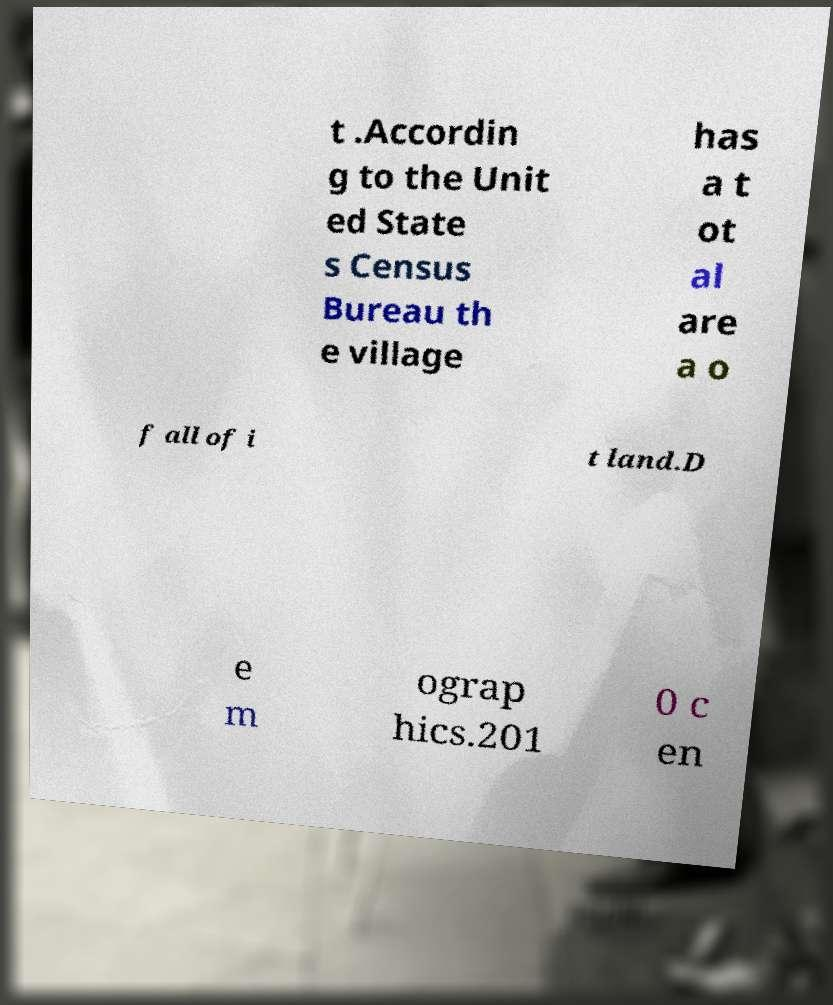What messages or text are displayed in this image? I need them in a readable, typed format. t .Accordin g to the Unit ed State s Census Bureau th e village has a t ot al are a o f all of i t land.D e m ograp hics.201 0 c en 